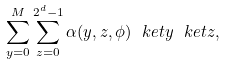<formula> <loc_0><loc_0><loc_500><loc_500>\sum _ { y = 0 } ^ { M } \sum _ { z = 0 } ^ { 2 ^ { d } - 1 } \alpha ( y , z , \phi ) \ k e t { y } \ k e t { z } ,</formula> 